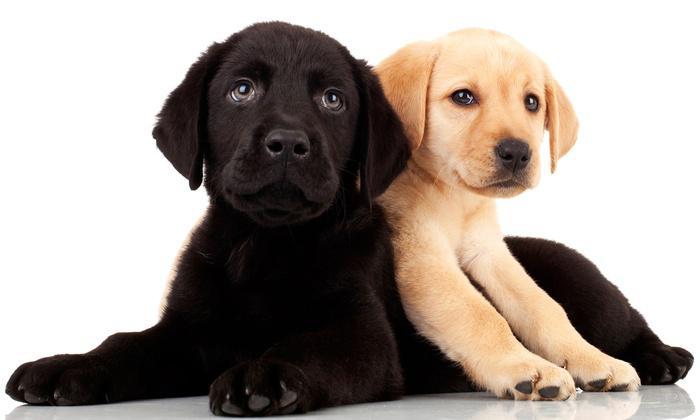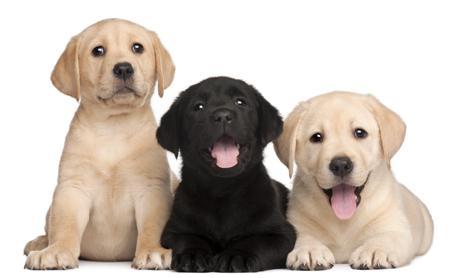The first image is the image on the left, the second image is the image on the right. Examine the images to the left and right. Is the description "An image contains one black puppy to the left of one tan puppy, and contains only two puppies." accurate? Answer yes or no. Yes. The first image is the image on the left, the second image is the image on the right. Considering the images on both sides, is "Two tan dogs and a black dog pose together in the image on the right." valid? Answer yes or no. Yes. 